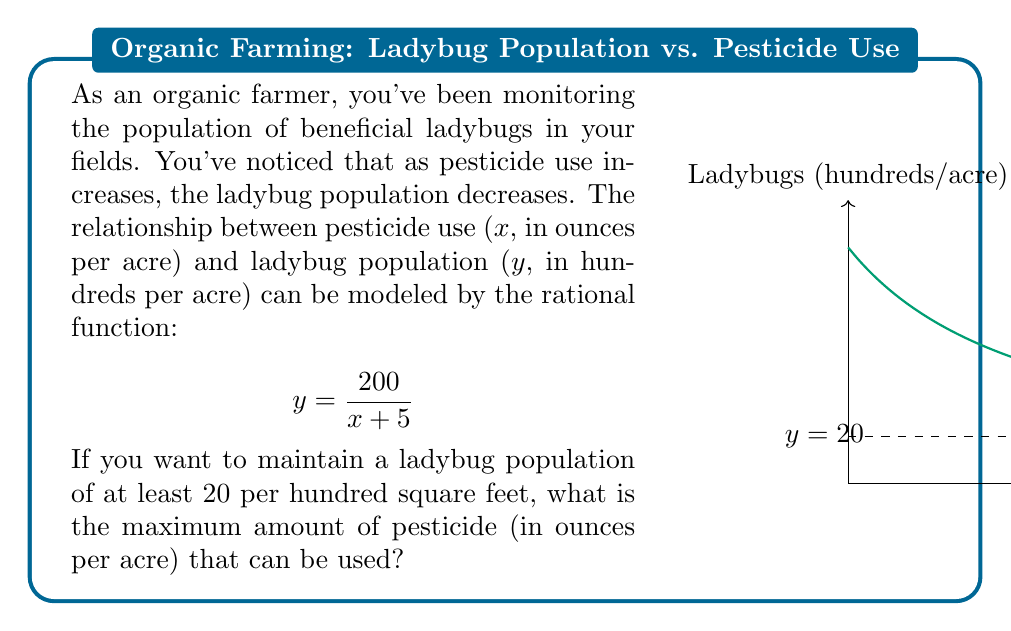Can you answer this question? Let's approach this step-by-step:

1) We want to find the maximum amount of pesticide (x) that allows for a ladybug population (y) of at least 20 per hundred square feet.

2) We can set up an inequality:

   $$\frac{200}{x + 5} \geq 20$$

3) To solve this, let's first multiply both sides by (x + 5):

   $$200 \geq 20(x + 5)$$

4) Expand the right side:

   $$200 \geq 20x + 100$$

5) Subtract 100 from both sides:

   $$100 \geq 20x$$

6) Divide both sides by 20:

   $$5 \geq x$$

7) Therefore, the maximum amount of pesticide that can be used is 5 ounces per acre.

This makes sense ecologically: as we increase pesticide use beyond 5 ounces per acre, the ladybug population will drop below 20 per hundred square feet, which is not desirable for our organic farming practices.
Answer: 5 ounces per acre 